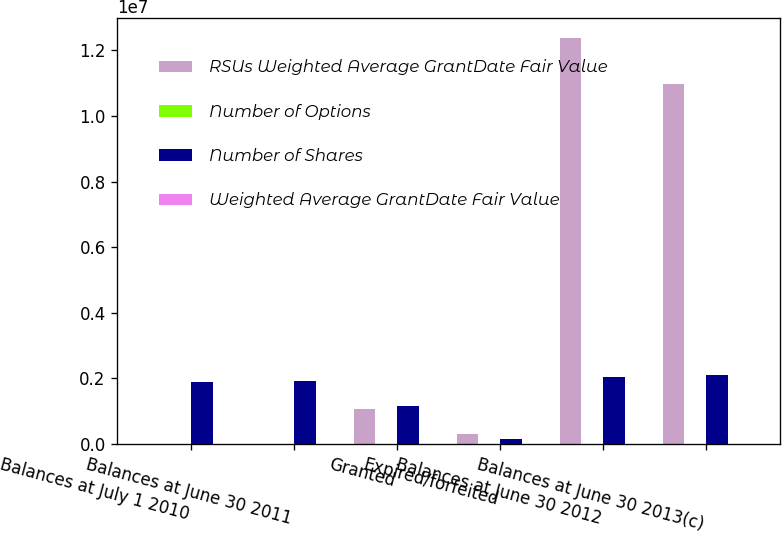<chart> <loc_0><loc_0><loc_500><loc_500><stacked_bar_chart><ecel><fcel>Balances at July 1 2010<fcel>Balances at June 30 2011<fcel>Granted<fcel>Expired/forfeited<fcel>Balances at June 30 2012<fcel>Balances at June 30 2013(c)<nl><fcel>RSUs Weighted Average GrantDate Fair Value<fcel>22.2<fcel>22.2<fcel>1.05754e+06<fcel>299163<fcel>1.23815e+07<fcel>1.09855e+07<nl><fcel>Number of Options<fcel>19.33<fcel>18.94<fcel>24.01<fcel>20.03<fcel>19.42<fcel>20.39<nl><fcel>Number of Shares<fcel>1.88417e+06<fcel>1.932e+06<fcel>1.14262e+06<fcel>161158<fcel>2.02557e+06<fcel>2.08683e+06<nl><fcel>Weighted Average GrantDate Fair Value<fcel>16.52<fcel>20.19<fcel>18.37<fcel>19.91<fcel>19.61<fcel>19.65<nl></chart> 